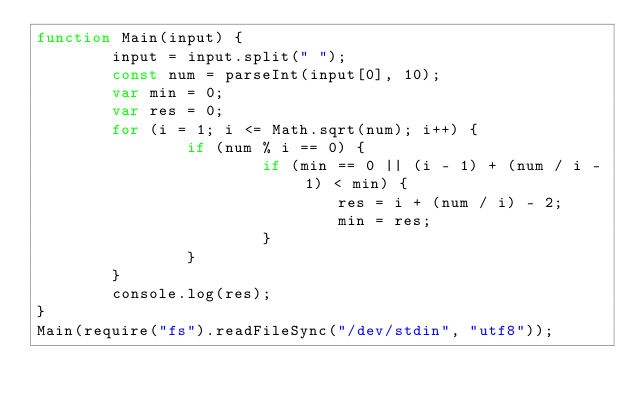Convert code to text. <code><loc_0><loc_0><loc_500><loc_500><_JavaScript_>function Main(input) {
		input = input.split(" ");
		const num = parseInt(input[0], 10);
		var min = 0;
		var res = 0;
		for (i = 1; i <= Math.sqrt(num); i++) {
				if (num % i == 0) {
						if (min == 0 || (i - 1) + (num / i - 1) < min) {
								res = i + (num / i) - 2;
								min = res;
						}
				}
		}
		console.log(res);
}
Main(require("fs").readFileSync("/dev/stdin", "utf8"));</code> 